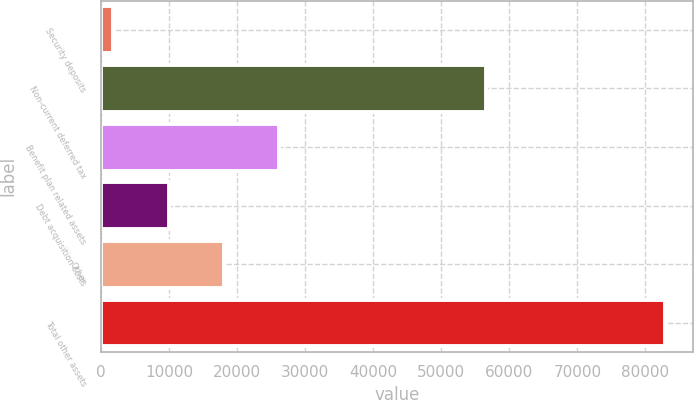Convert chart to OTSL. <chart><loc_0><loc_0><loc_500><loc_500><bar_chart><fcel>Security deposits<fcel>Non-current deferred tax<fcel>Benefit plan related assets<fcel>Debt acquisition costs<fcel>Other<fcel>Total other assets<nl><fcel>1862<fcel>56627<fcel>26173.7<fcel>9965.9<fcel>18069.8<fcel>82901<nl></chart> 